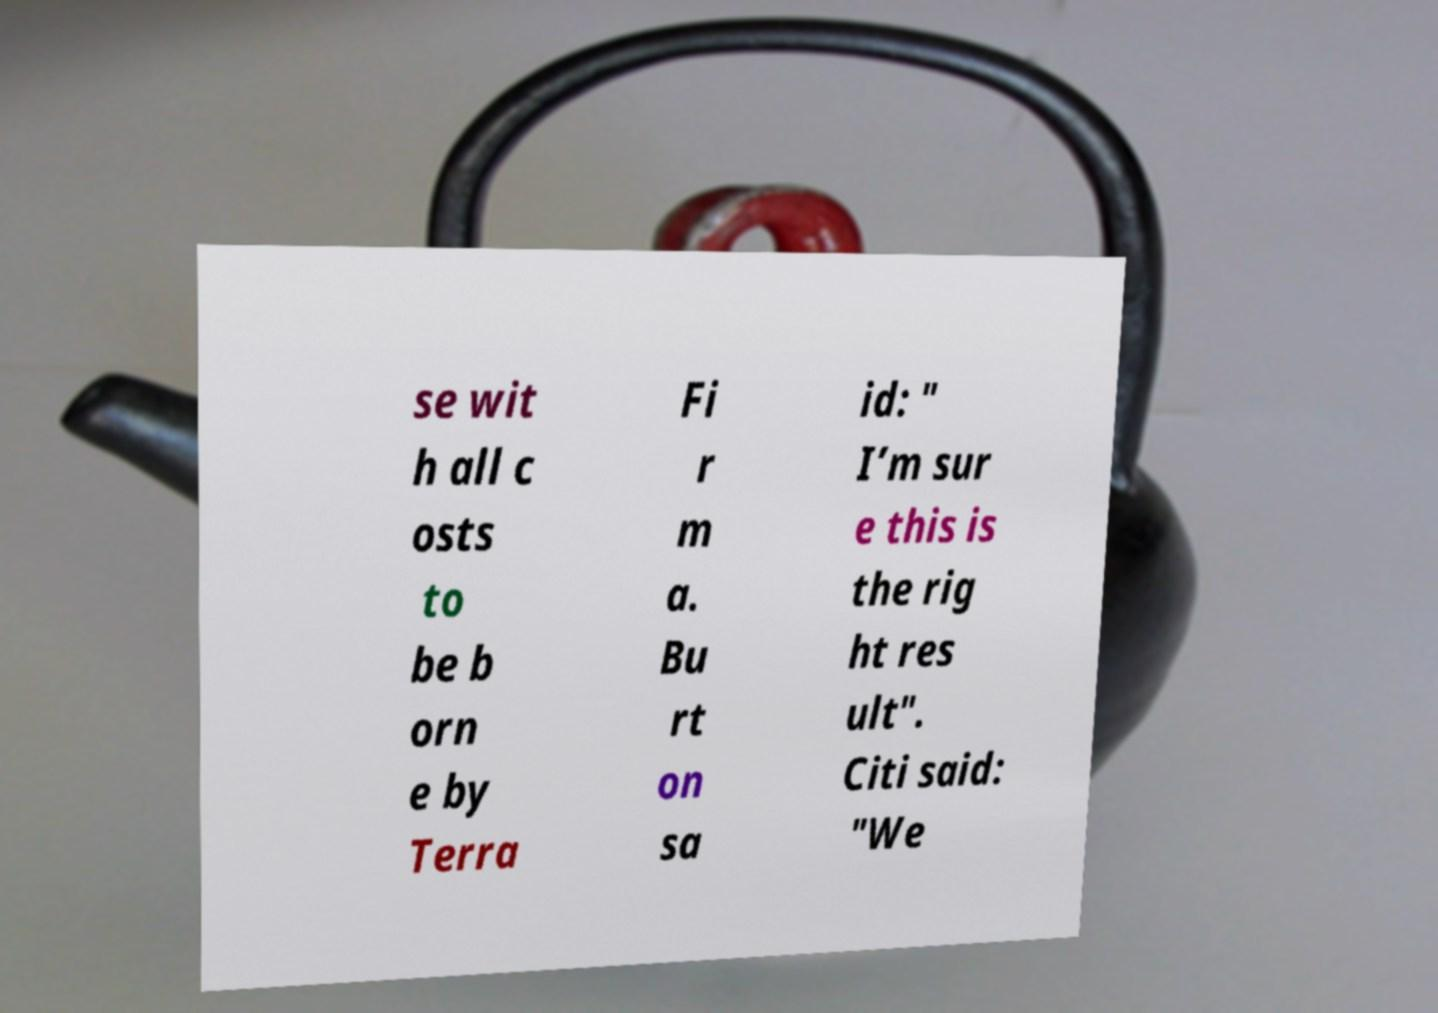Could you extract and type out the text from this image? se wit h all c osts to be b orn e by Terra Fi r m a. Bu rt on sa id: " I’m sur e this is the rig ht res ult". Citi said: "We 